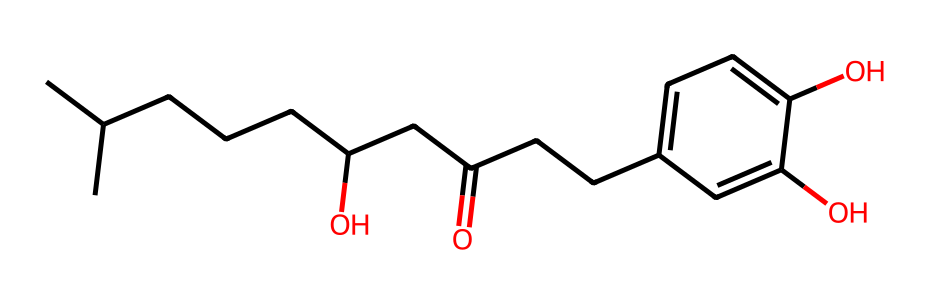What is the total number of carbon atoms in the structure? By counting the number of carbon atoms represented in the SMILES notation, we find a total of 17 carbon atoms (C).
Answer: 17 How many hydroxyl (OH) groups are present in this compound? The structure indicates there are two hydroxyl groups, as denoted by the '(O)' in the SMILES.
Answer: 2 Is the compound predominantly branched or linear? The structure has a significant number of branches (e.g., the presence of isoprenoid suggestions), indicating it is predominantly branched.
Answer: branched What is the functional group indicated by ‘(O)’ in the structure? The ‘(O)’ in the SMILES indicates the presence of hydroxyl (-OH) groups in the chemical structure.
Answer: hydroxyl Which part of this chemical structure contributes to its aromaticity? The cyclic component with alternating double bonds, evident in 'c1ccc(O)c(O)', contributes to the compound's aromaticity.
Answer: aromatic ring What type of compound is indicated by this chemical structure? Based on the presence of both the hydroxyl groups and an aromatic ring, this compound is classified as a phenolic compound.
Answer: phenolic compound 